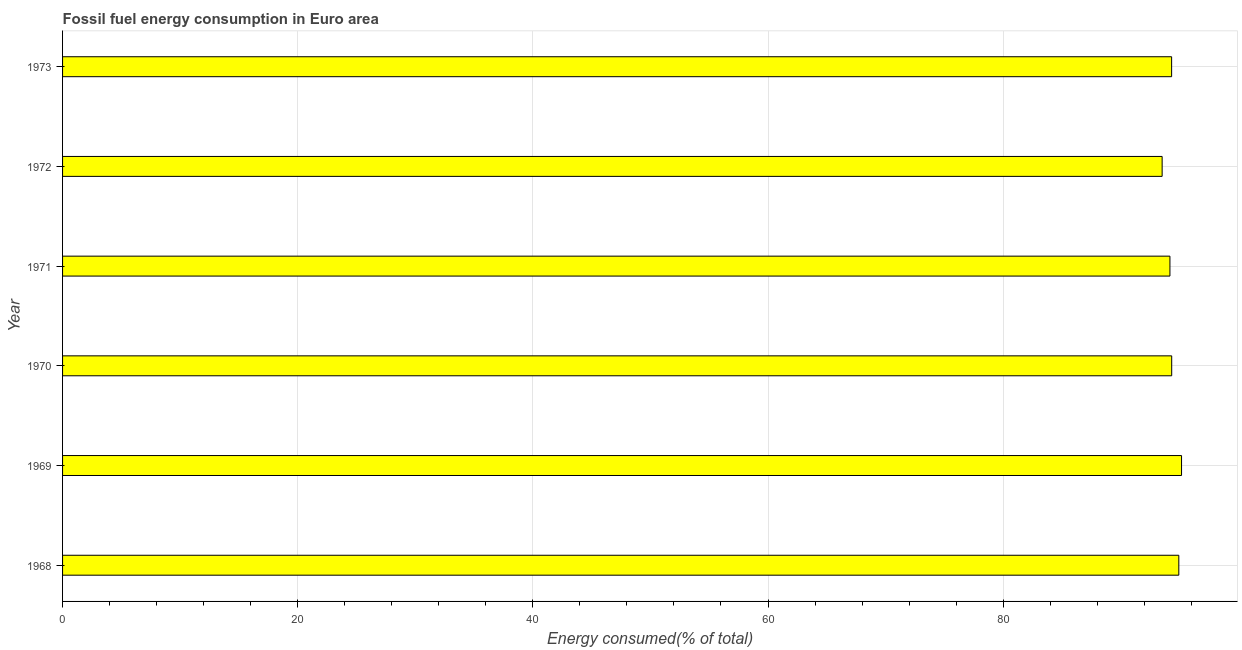Does the graph contain any zero values?
Provide a short and direct response. No. What is the title of the graph?
Make the answer very short. Fossil fuel energy consumption in Euro area. What is the label or title of the X-axis?
Make the answer very short. Energy consumed(% of total). What is the label or title of the Y-axis?
Your answer should be compact. Year. What is the fossil fuel energy consumption in 1971?
Provide a short and direct response. 94.18. Across all years, what is the maximum fossil fuel energy consumption?
Make the answer very short. 95.17. Across all years, what is the minimum fossil fuel energy consumption?
Offer a terse response. 93.52. In which year was the fossil fuel energy consumption maximum?
Keep it short and to the point. 1969. In which year was the fossil fuel energy consumption minimum?
Keep it short and to the point. 1972. What is the sum of the fossil fuel energy consumption?
Your answer should be very brief. 566.48. What is the difference between the fossil fuel energy consumption in 1969 and 1972?
Offer a terse response. 1.65. What is the average fossil fuel energy consumption per year?
Ensure brevity in your answer.  94.41. What is the median fossil fuel energy consumption?
Keep it short and to the point. 94.33. In how many years, is the fossil fuel energy consumption greater than 60 %?
Keep it short and to the point. 6. Do a majority of the years between 1968 and 1969 (inclusive) have fossil fuel energy consumption greater than 4 %?
Your response must be concise. Yes. Is the fossil fuel energy consumption in 1971 less than that in 1972?
Make the answer very short. No. Is the difference between the fossil fuel energy consumption in 1971 and 1972 greater than the difference between any two years?
Give a very brief answer. No. What is the difference between the highest and the second highest fossil fuel energy consumption?
Your response must be concise. 0.23. Is the sum of the fossil fuel energy consumption in 1971 and 1973 greater than the maximum fossil fuel energy consumption across all years?
Ensure brevity in your answer.  Yes. What is the difference between the highest and the lowest fossil fuel energy consumption?
Keep it short and to the point. 1.65. How many years are there in the graph?
Give a very brief answer. 6. Are the values on the major ticks of X-axis written in scientific E-notation?
Offer a very short reply. No. What is the Energy consumed(% of total) of 1968?
Offer a terse response. 94.94. What is the Energy consumed(% of total) of 1969?
Keep it short and to the point. 95.17. What is the Energy consumed(% of total) of 1970?
Your response must be concise. 94.34. What is the Energy consumed(% of total) of 1971?
Your answer should be very brief. 94.18. What is the Energy consumed(% of total) in 1972?
Make the answer very short. 93.52. What is the Energy consumed(% of total) in 1973?
Your answer should be very brief. 94.33. What is the difference between the Energy consumed(% of total) in 1968 and 1969?
Provide a short and direct response. -0.23. What is the difference between the Energy consumed(% of total) in 1968 and 1970?
Offer a very short reply. 0.6. What is the difference between the Energy consumed(% of total) in 1968 and 1971?
Provide a short and direct response. 0.76. What is the difference between the Energy consumed(% of total) in 1968 and 1972?
Give a very brief answer. 1.42. What is the difference between the Energy consumed(% of total) in 1968 and 1973?
Offer a very short reply. 0.61. What is the difference between the Energy consumed(% of total) in 1969 and 1970?
Give a very brief answer. 0.84. What is the difference between the Energy consumed(% of total) in 1969 and 1971?
Provide a short and direct response. 0.99. What is the difference between the Energy consumed(% of total) in 1969 and 1972?
Your response must be concise. 1.65. What is the difference between the Energy consumed(% of total) in 1969 and 1973?
Your response must be concise. 0.84. What is the difference between the Energy consumed(% of total) in 1970 and 1971?
Offer a very short reply. 0.15. What is the difference between the Energy consumed(% of total) in 1970 and 1972?
Ensure brevity in your answer.  0.81. What is the difference between the Energy consumed(% of total) in 1970 and 1973?
Give a very brief answer. 0.01. What is the difference between the Energy consumed(% of total) in 1971 and 1972?
Keep it short and to the point. 0.66. What is the difference between the Energy consumed(% of total) in 1971 and 1973?
Keep it short and to the point. -0.14. What is the difference between the Energy consumed(% of total) in 1972 and 1973?
Give a very brief answer. -0.81. What is the ratio of the Energy consumed(% of total) in 1969 to that in 1970?
Make the answer very short. 1.01. What is the ratio of the Energy consumed(% of total) in 1969 to that in 1972?
Make the answer very short. 1.02. What is the ratio of the Energy consumed(% of total) in 1969 to that in 1973?
Provide a succinct answer. 1.01. What is the ratio of the Energy consumed(% of total) in 1970 to that in 1971?
Make the answer very short. 1. What is the ratio of the Energy consumed(% of total) in 1970 to that in 1972?
Your answer should be compact. 1.01. What is the ratio of the Energy consumed(% of total) in 1971 to that in 1972?
Your answer should be compact. 1.01. What is the ratio of the Energy consumed(% of total) in 1972 to that in 1973?
Your answer should be compact. 0.99. 